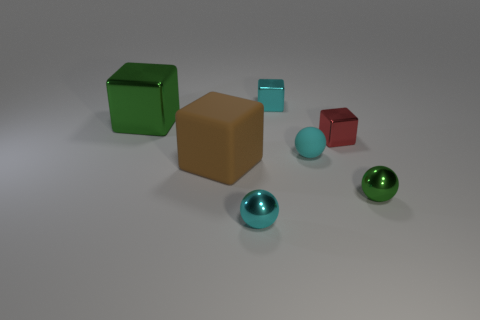Subtract all yellow balls. Subtract all blue blocks. How many balls are left? 3 Add 2 small metal balls. How many objects exist? 9 Subtract all balls. How many objects are left? 4 Subtract all big yellow cubes. Subtract all small cyan shiny spheres. How many objects are left? 6 Add 4 brown objects. How many brown objects are left? 5 Add 6 brown blocks. How many brown blocks exist? 7 Subtract 0 blue cubes. How many objects are left? 7 